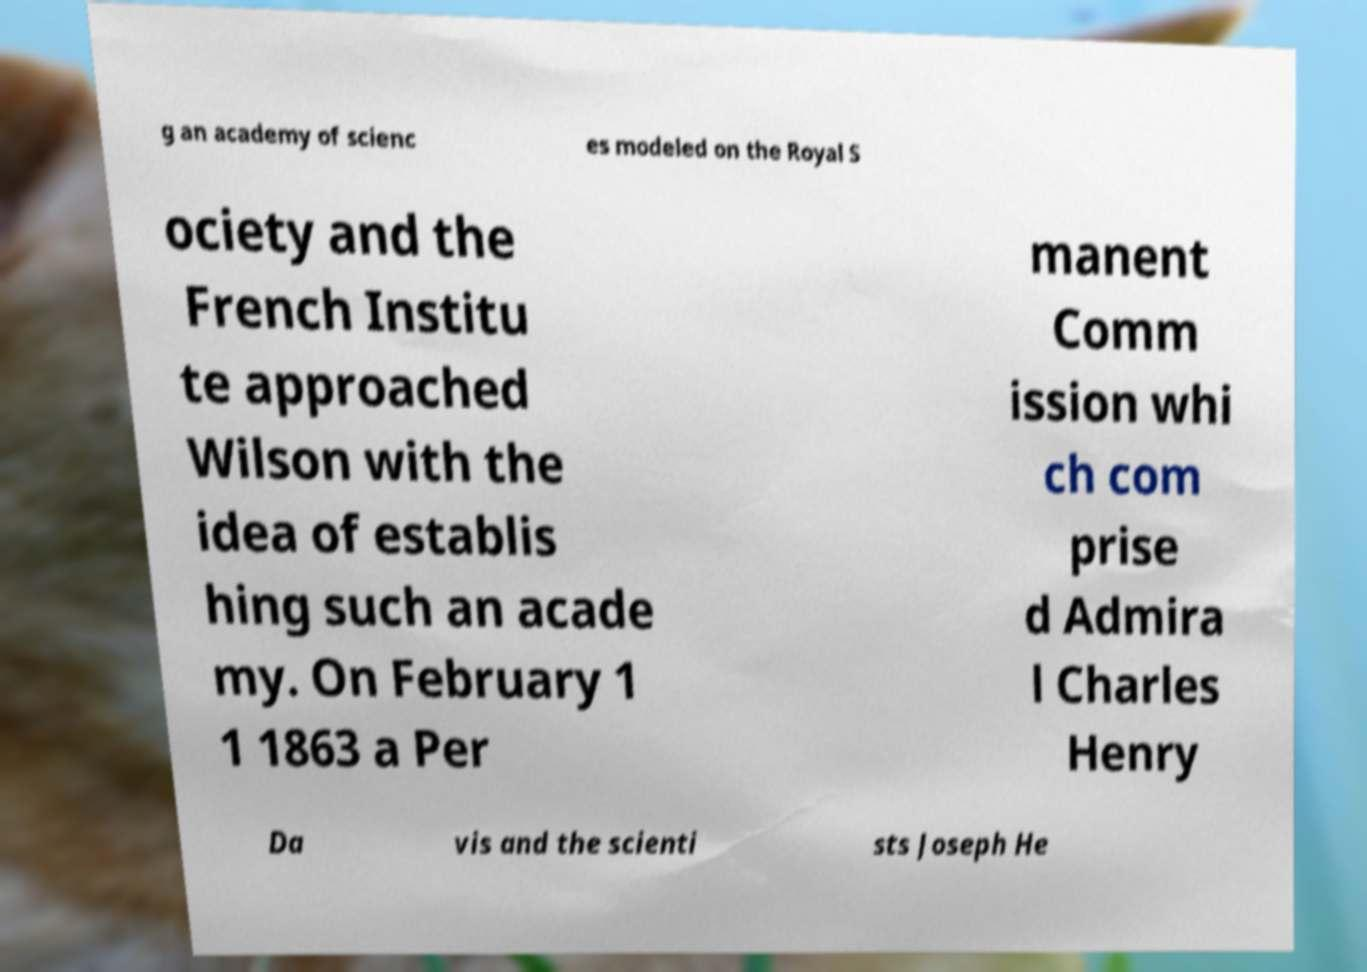Could you extract and type out the text from this image? g an academy of scienc es modeled on the Royal S ociety and the French Institu te approached Wilson with the idea of establis hing such an acade my. On February 1 1 1863 a Per manent Comm ission whi ch com prise d Admira l Charles Henry Da vis and the scienti sts Joseph He 